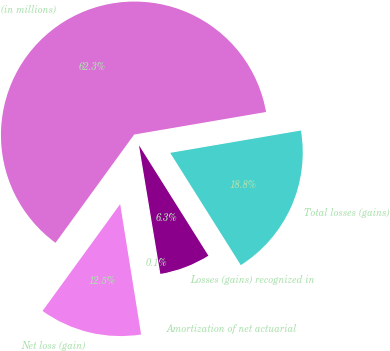Convert chart. <chart><loc_0><loc_0><loc_500><loc_500><pie_chart><fcel>(in millions)<fcel>Net loss (gain)<fcel>Amortization of net actuarial<fcel>Losses (gains) recognized in<fcel>Total losses (gains)<nl><fcel>62.3%<fcel>12.53%<fcel>0.09%<fcel>6.31%<fcel>18.76%<nl></chart> 